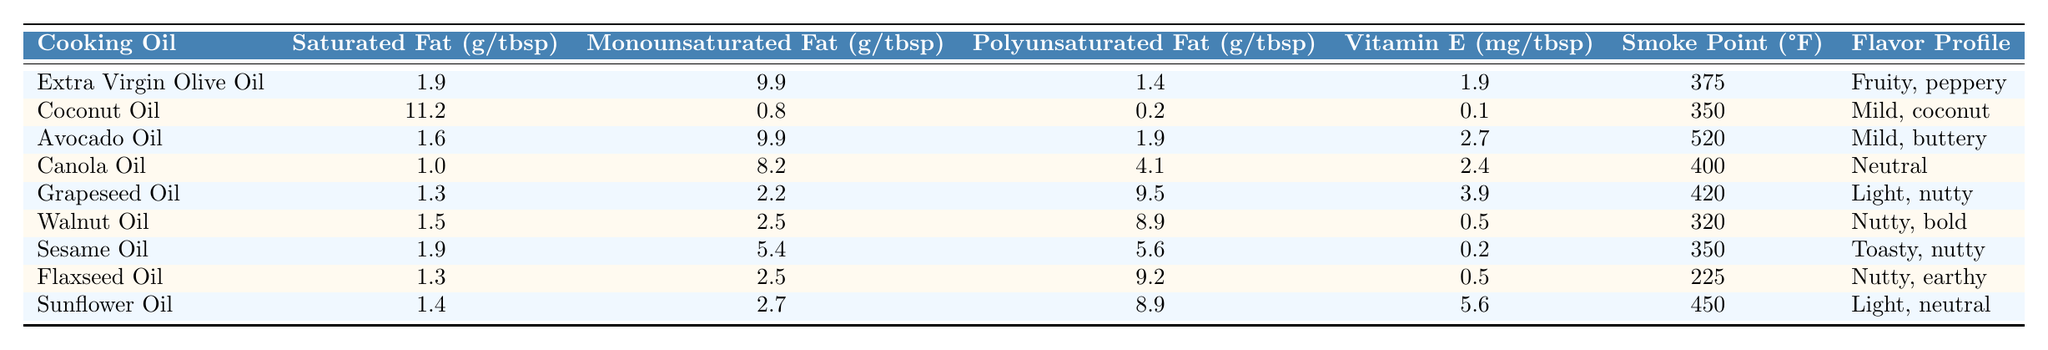What is the smoke point of Avocado Oil? The smoke point of a cooking oil is listed in the column for "Smoke Point (°F)." Looking at the row for Avocado Oil, it shows a smoke point of 520°F.
Answer: 520°F Which cooking oil has the highest Saturated Fat content? To find the cooking oil with the highest Saturated Fat content, we compare the values in the "Saturated Fat (g/tbsp)" column. Coconut Oil has the highest value at 11.2 g/tbsp.
Answer: Coconut Oil What is the average Monounsaturated Fat content across all oils? First, we sum all the Monounsaturated Fat values: 9.9 + 0.8 + 9.9 + 8.2 + 2.2 + 2.5 + 5.4 + 2.5 + 2.7 = 43.1 g. There are 9 cooking oils, so the average is 43.1g / 9 = approximately 4.79 g/tbsp.
Answer: 4.79 g/tbsp Does Flaxseed Oil contain more Polyunsaturated Fat than Walnut Oil? Looking at the "Polyunsaturated Fat (g/tbsp)" column, Flaxseed Oil has 9.2 g/tbsp and Walnut Oil has 8.9 g/tbsp. Since 9.2 is greater than 8.9, Flaxseed Oil does indeed contain more Polyunsaturated Fat.
Answer: Yes Which cooking oil provides the most Vitamin E? We check the "Vitamin E (mg/tbsp)" column for the highest value. Sunflower Oil lists 5.6 mg/tbsp, which is the highest among all the oils in the table.
Answer: Sunflower Oil How much more Saturated Fat does Coconut Oil have than Canola Oil? From the Saturated Fat column, Coconut Oil has 11.2 g/tbsp and Canola Oil has 1.0 g/tbsp. The difference is 11.2 - 1.0 = 10.2 g/tbsp.
Answer: 10.2 g/tbsp Which oil has the lowest smoke point, and what is that value? Checking the "Smoke Point (°F)" column reveals that Flaxseed Oil has the lowest smoke point at 225°F.
Answer: 225°F Is the flavor profile of Sesame Oil nutty? Referencing the "Flavor Profile" column, Sesame Oil is described as "Toasty, nutty," confirming that it has a nutty flavor profile.
Answer: Yes If we were to list all oils in order of their smoke point from highest to lowest, which oil comes in second? The oils listed by smoke point in descending order are Avocado Oil (520°F), Sunflower Oil (450°F), and then Grapeseed Oil (420°F) follows next. Thus, Sunflower Oil is the second highest.
Answer: Sunflower Oil Which oil has the most balance between Monounsaturated and Polyunsaturated fats? Evaluating the balance, we can see that Canola Oil has 8.2 g of Monounsaturated Fat and 4.1 g of Polyunsaturated Fat, which indicates a good proportion between the two.
Answer: Canola Oil 